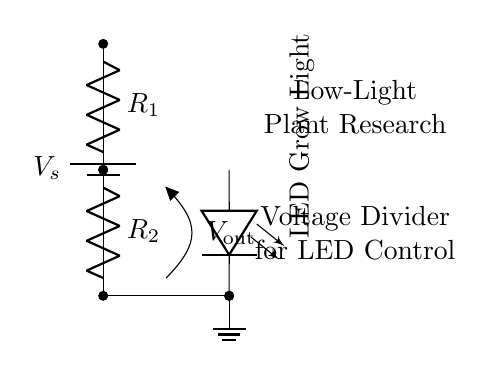What is the purpose of the resistors in this circuit? The resistors are used to create a voltage divider, which adjusts the output voltage to a desired level for the LED grow light.
Answer: Voltage divider What are the labels of the components shown in the diagram? The labels in the diagram include a battery labeled as V_s, resistors labeled R_1 and R_2, and an LED grow light.
Answer: V_s, R_1, R_2, LED Grow Light What is the output voltage in this circuit called? The output voltage is designated as V_out, which reflects the voltage drop across the resistors and controls the LED.
Answer: V_out What are the effects of changing R_1 or R_2 on the output voltage? Changing R_1 or R_2 alters the voltage drop across them, which in turn adjusts the output voltage V_out to the LED grow light, affecting its brightness.
Answer: Adjusts brightness Which component provides the power source for this circuit? The power source in this circuit is the battery, which supplies the voltage necessary for the operation of the entire circuit.
Answer: Battery How do the resistors interact to control the LED’s power supply? The resistors interact by creating a voltage divider; the ratio of their values determines the proportion of voltage supplied to the LED grow light, thus controlling its brightness.
Answer: Voltage divider ratio 